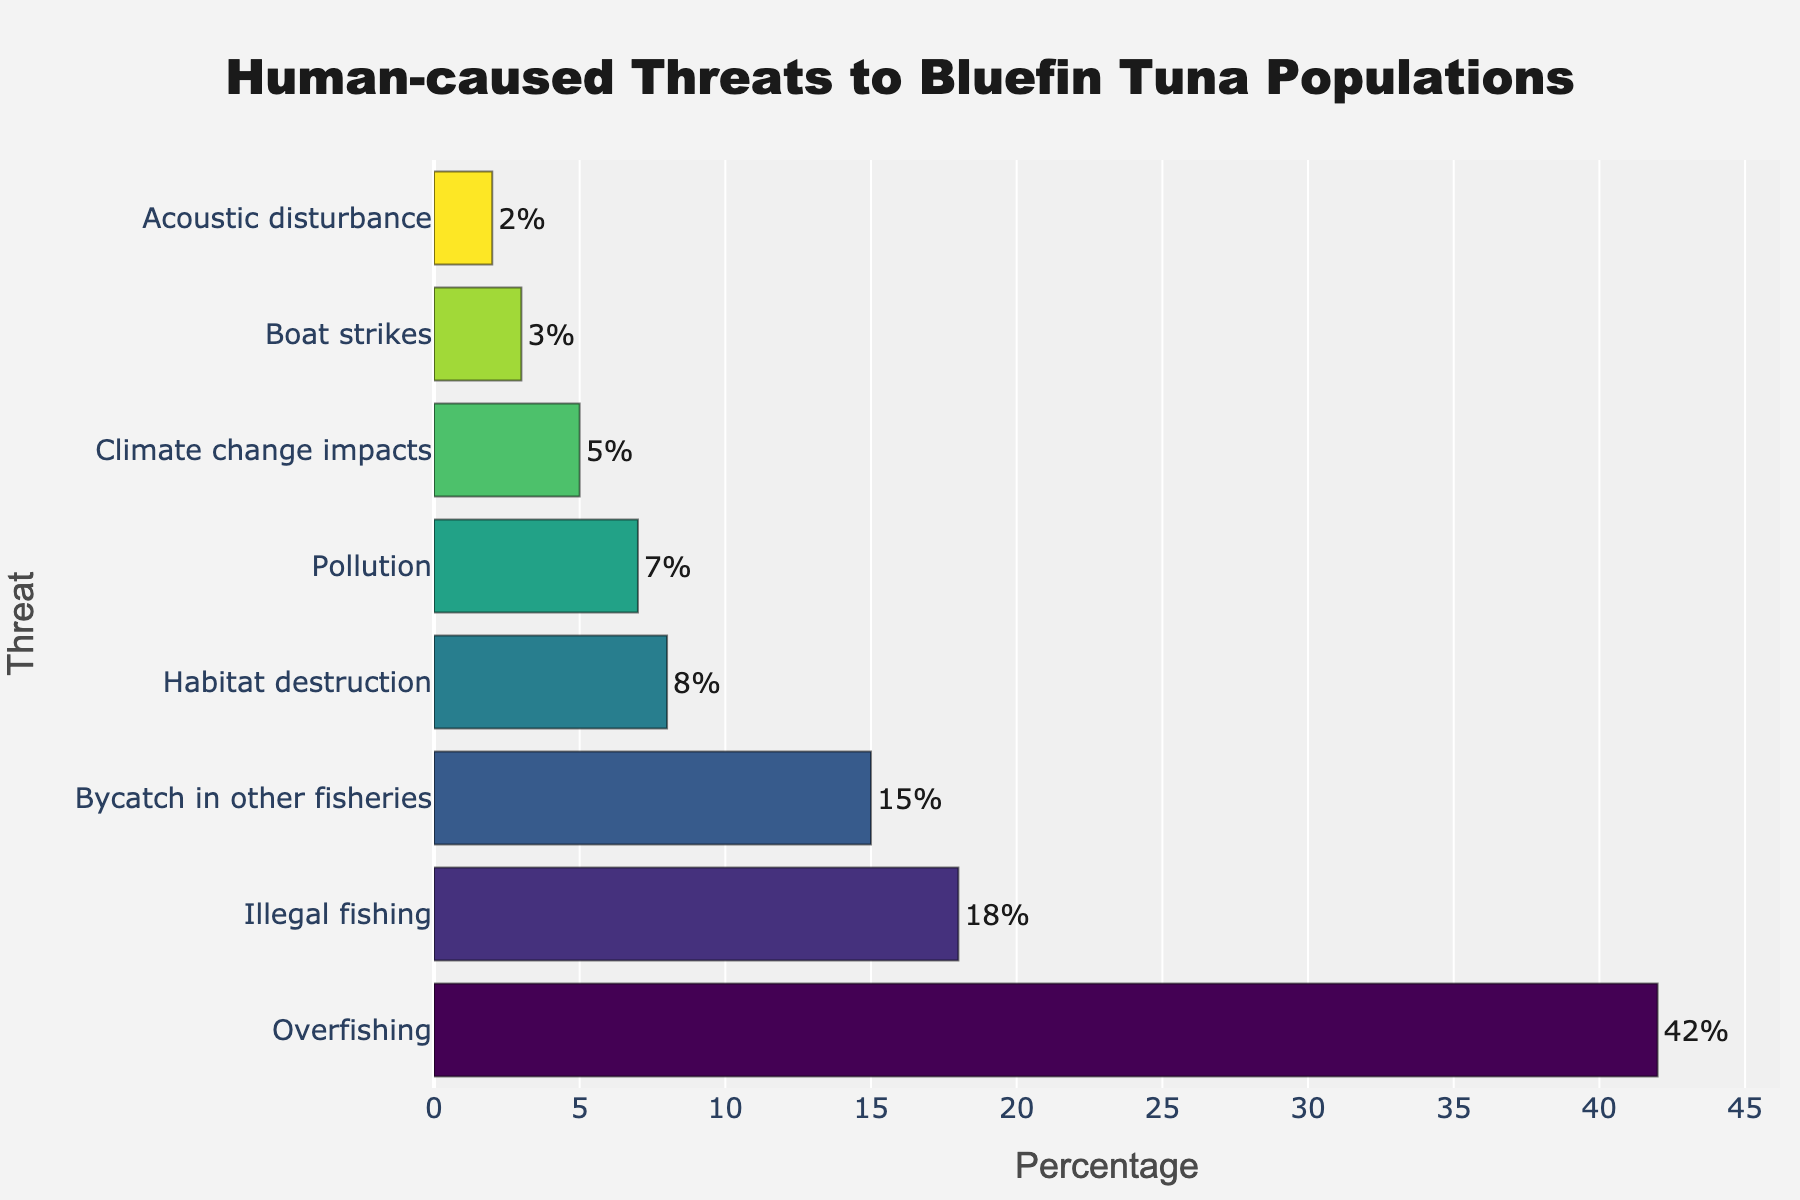What is the most significant human-caused threat to Bluefin tuna populations? The bar chart shows the percentage breakdown of threats, and the longest bar represents the greatest threat. Overfishing has the longest bar, indicating it is the most significant threat.
Answer: Overfishing What is the combined percentage of illegal fishing, habitat destruction, and pollution threats to Bluefin tuna populations? To find the combined percentage, add the individual percentages of illegal fishing (18%), habitat destruction (8%), and pollution (7%). The sum is 18 + 8 + 7 = 33%.
Answer: 33% How does the percentage of bycatch in other fisheries compare to the percentage of pollution? By looking at the lengths of the bars for these two categories, the bar for bycatch in other fisheries (15%) is longer than the bar for pollution (7%).
Answer: Bycatch in other fisheries is greater than pollution Which threats have a percentage lower than 10%? From the chart, threats with bars that do not extend past the 10% mark include habitat destruction (8%), pollution (7%), climate change impacts (5%), boat strikes (3%), and acoustic disturbance (2%).
Answer: Habitat destruction, pollution, climate change impacts, boat strikes, acoustic disturbance What is the difference in percentage between overfishing and climate change impacts? The percentage for overfishing is 42%, and for climate change impacts it is 5%. The difference is calculated as 42 - 5 = 37%.
Answer: 37% How many threats have a percentage higher than 15%? By examining the bars in the chart, overfishing (42%), illegal fishing (18%), and bycatch in other fisheries (15%) are identified. There are 3 threats in total.
Answer: 3 What is the range of percentages shown in the chart? The range is calculated by subtracting the smallest percentage (acoustic disturbance, 2%) from the largest percentage (overfishing, 42%). The range is 42 - 2 = 40%.
Answer: 40% Which threat has the shortest bar, and what is its percentage? By examining the chart, the shortest bar corresponds to acoustic disturbance, and its percentage is 2%.
Answer: Acoustic disturbance, 2% 